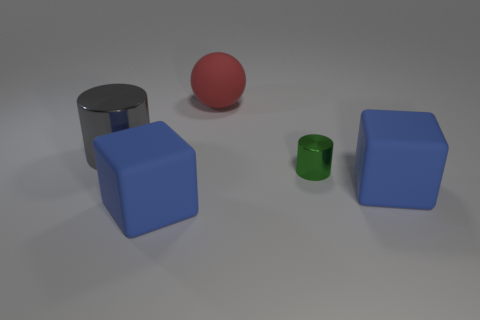Are there fewer small yellow balls than large cylinders?
Give a very brief answer. Yes. There is a cylinder that is the same size as the red thing; what is it made of?
Offer a very short reply. Metal. Is the number of large rubber blocks greater than the number of big cylinders?
Your answer should be compact. Yes. How many other objects are there of the same color as the small object?
Your answer should be compact. 0. How many rubber objects are both on the left side of the small thing and in front of the red object?
Give a very brief answer. 1. Is there anything else that has the same size as the red sphere?
Keep it short and to the point. Yes. Are there more large rubber blocks behind the small metal cylinder than large rubber spheres that are right of the red rubber object?
Your answer should be very brief. No. There is a cube that is on the right side of the tiny object; what is it made of?
Give a very brief answer. Rubber. Do the green thing and the red matte thing right of the gray object have the same shape?
Provide a short and direct response. No. There is a rubber thing that is to the right of the cylinder that is on the right side of the gray object; what number of matte things are in front of it?
Your answer should be compact. 1. 